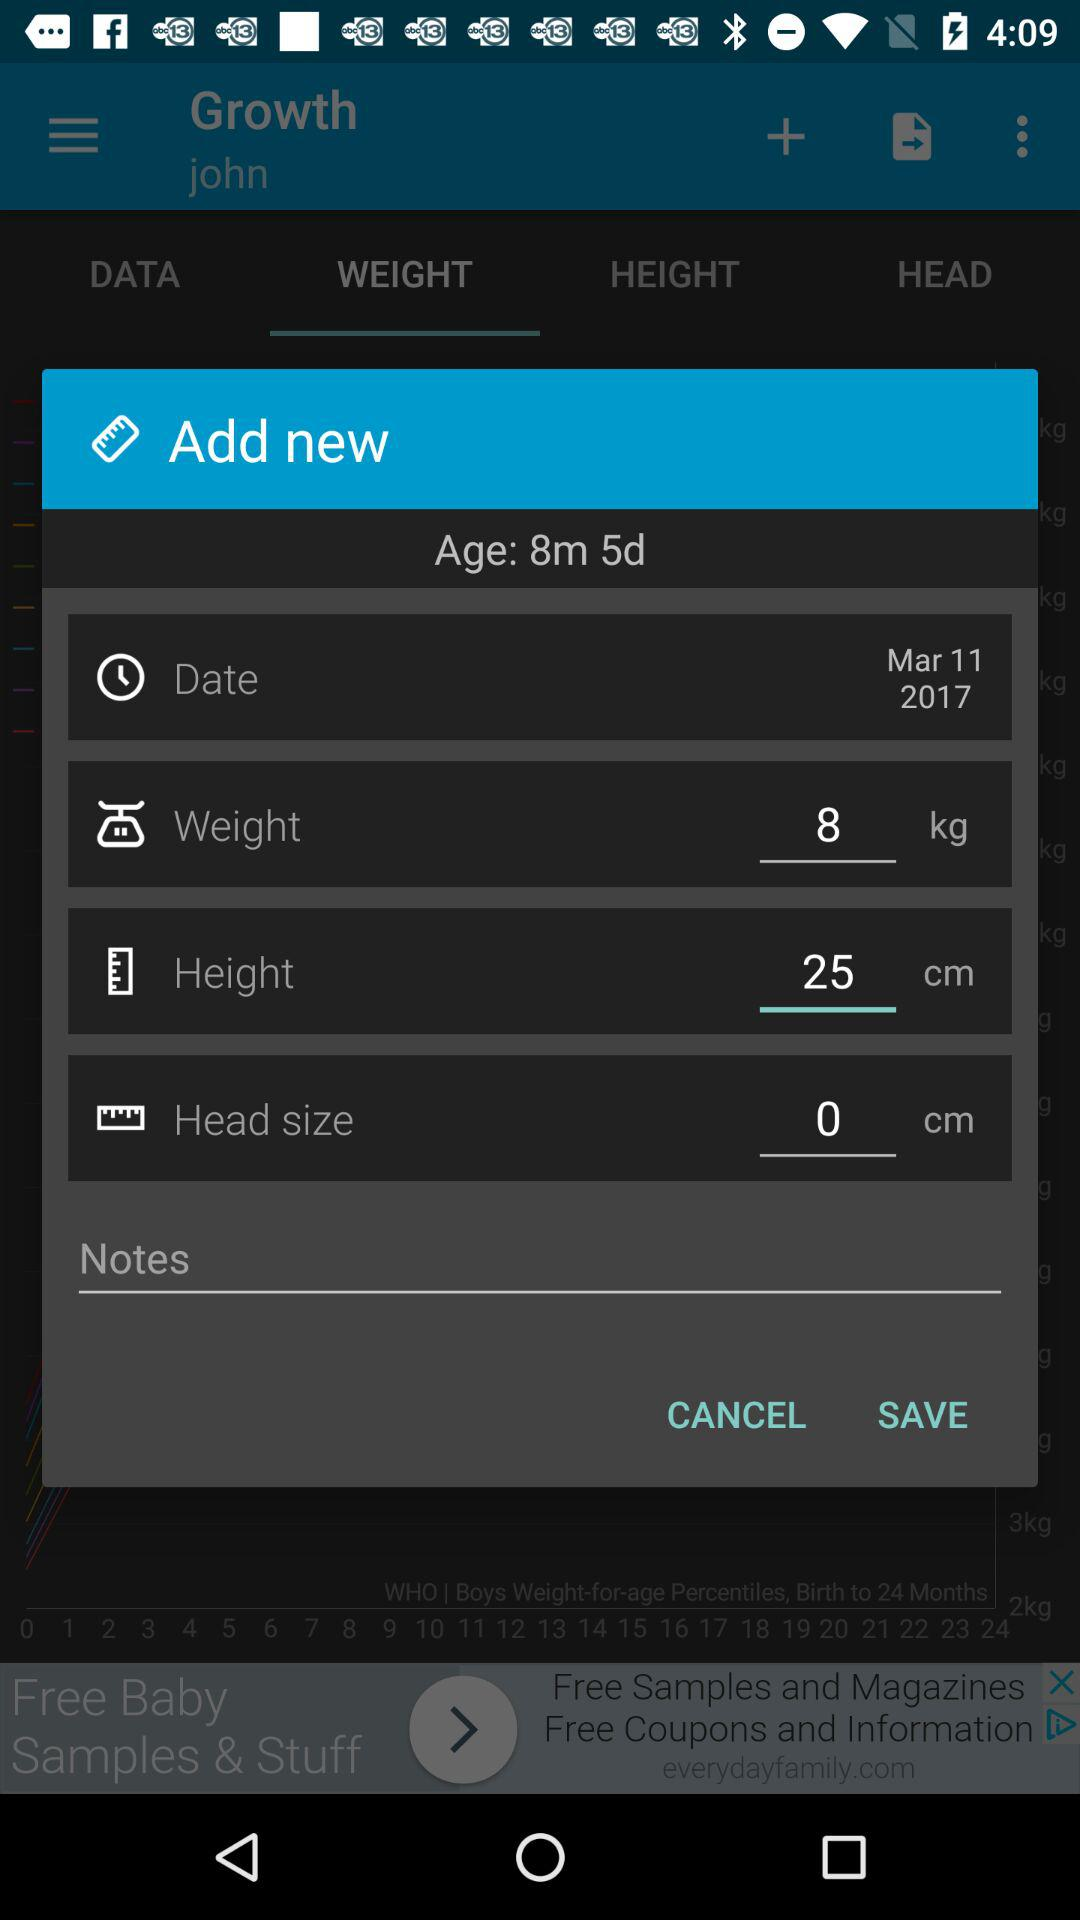How many more centimeters is the baby's height than their head size? The question seems to be based on a misunderstanding as the data fields showing the baby's height and head size are not filled in with comparable data. The height is listed as 25 cm, but the head size is listed as 0 cm, which is likely a placeholder or an error since a measurement hasn’t been entered yet. 